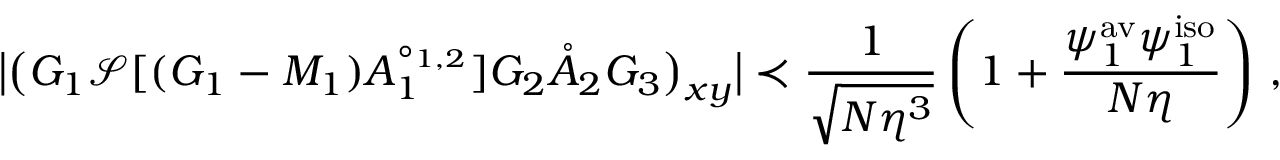Convert formula to latex. <formula><loc_0><loc_0><loc_500><loc_500>\left | \left ( G _ { 1 } \mathcal { S } [ ( G _ { 1 } - M _ { 1 } ) A _ { 1 } ^ { \circ _ { 1 , 2 } } ] G _ { 2 } \mathring { A } _ { 2 } G _ { 3 } \right ) _ { x y } \right | \prec \frac { 1 } { \sqrt { N \eta ^ { 3 } } } \left ( 1 + \frac { \psi _ { 1 } ^ { a v } \psi _ { 1 } ^ { i s o } } { N \eta } \right ) \, ,</formula> 